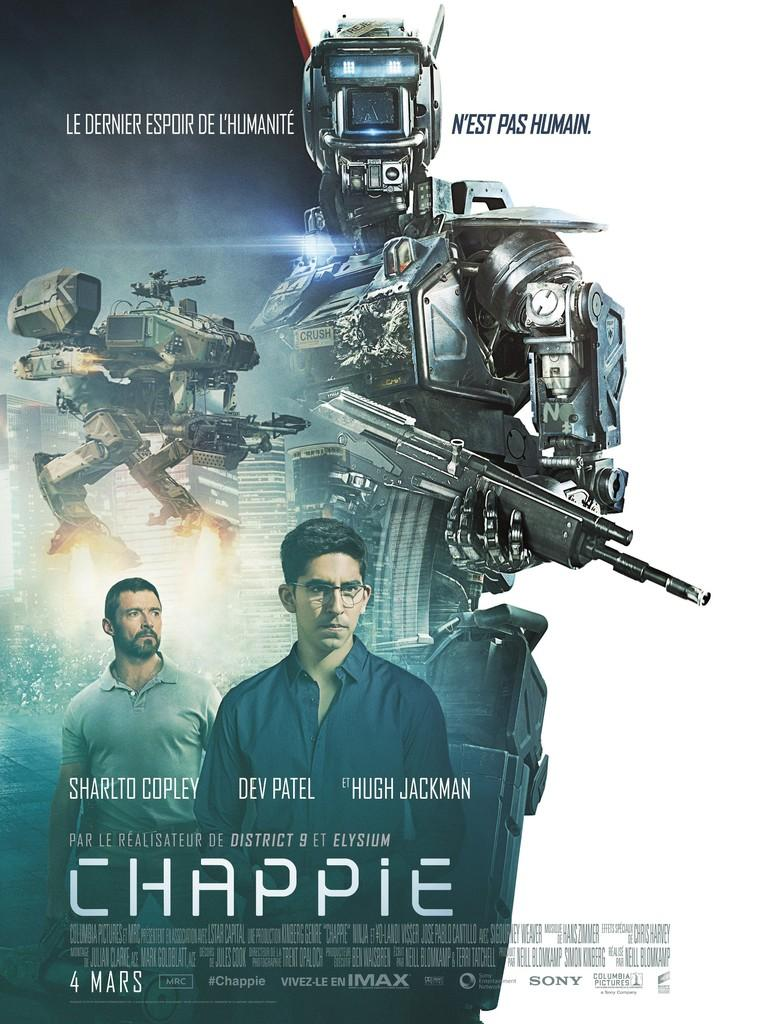Provide a one-sentence caption for the provided image. The cover to a movie called Chappie starring Hugh Jackman. 